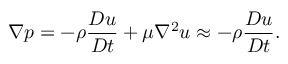Convert formula to latex. <formula><loc_0><loc_0><loc_500><loc_500>\nabla p = - \rho \frac { D u } { D t } + \mu \nabla ^ { 2 } u \approx - \rho \frac { D u } { D t } .</formula> 